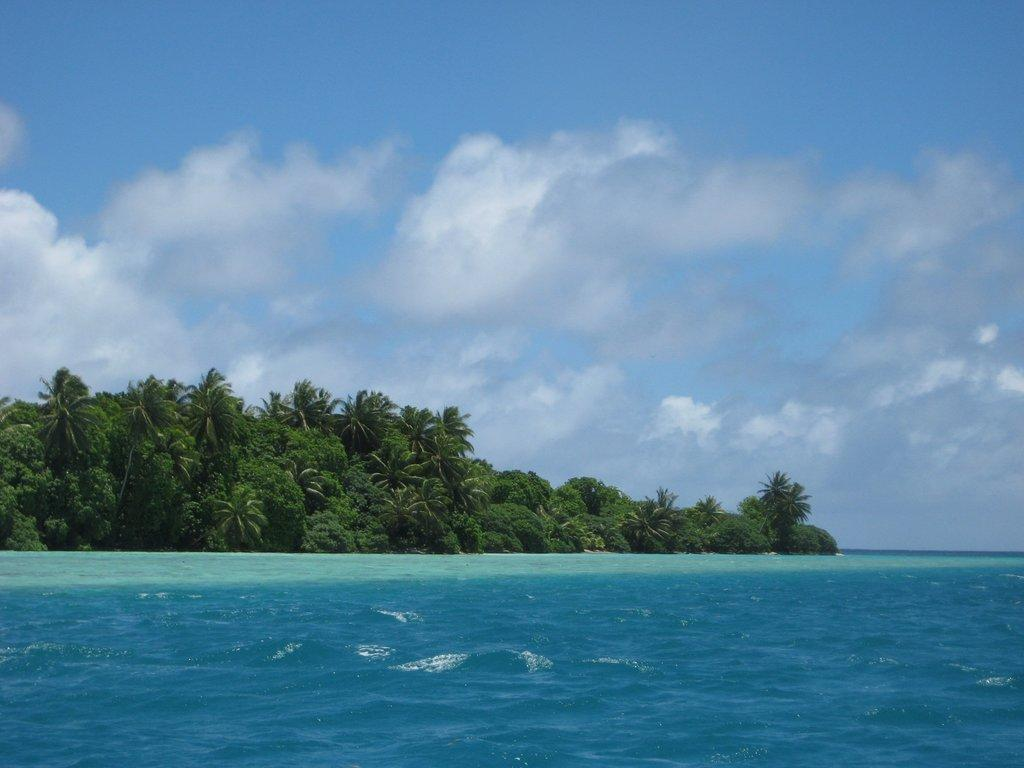What is the primary element visible in the image? There is water in the image. What type of vegetation can be seen in the image? There are trees in the image. What is the condition of the sky in the image? The sky is clear in the image. Where is the sink located in the image? There is no sink present in the image. What type of net can be seen in the image? There is no net present in the image. 